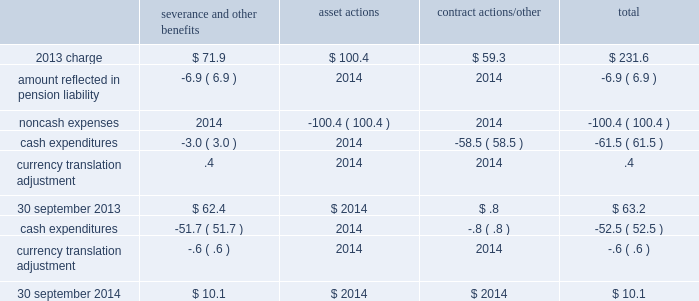Business restructuring and cost reduction actions the charges we record for business restructuring and cost reduction actions have been excluded from segment operating income and are reflected on the consolidated income statements as 201cbusiness restructuring and cost reduction actions . 201d 2014 charge on 18 september 2014 , we announced plans to reorganize the company , including realignment of our businesses in new reporting segments and organizational changes , effective as of 1 october 2014 .
Refer to note 25 , business segment and geographic information , for additional details .
As a result of this initiative , we will incur ongoing severance and other charges .
During the fourth quarter of 2014 , an expense of $ 12.7 ( $ 8.2 after-tax , or $ .04 per share ) was incurred relating to the elimination of approximately 50 positions .
The 2014 charge related to the businesses at the segment level as follows : $ 4.4 in merchant gases , $ 4.1 in tonnage gases , $ 2.4 in electronics and performance materials , and $ 1.8 in equipment and energy .
2013 plan during the fourth quarter of 2013 , we recorded an expense of $ 231.6 ( $ 157.9 after-tax , or $ .74 per share ) reflecting actions to better align our cost structure with current market conditions .
The asset and contract actions primarily impacted the electronics business due to continued weakness in the photovoltaic ( pv ) and light-emitting diode ( led ) markets .
The severance and other contractual benefits primarily impacted our merchant gases business and corporate functions in response to weaker than expected business conditions in europe and asia , reorganization of our operations and functional areas , and previously announced senior executive changes .
The remaining planned actions associated with severance were completed in the first quarter of 2015 .
The 2013 charges relate to the businesses at the segment level as follows : $ 61.0 in merchant gases , $ 28.6 in tonnage gases , $ 141.0 in electronics and performance materials , and $ 1.0 in equipment and energy .
The table summarizes the carrying amount of the accrual for the 2013 plan at 30 september 2014 : severance and other benefits actions contract actions/other total .

Considering the expenses of the 2013 charge , what were the impact of the severance and other benefits on the total value? 
Rationale: it is the value of the severance and other benefits divided by the total expenses of the 2013 charge , then turned into a percentage to represent the impact .
Computations: (71.9 / 231.6)
Answer: 0.31045. 